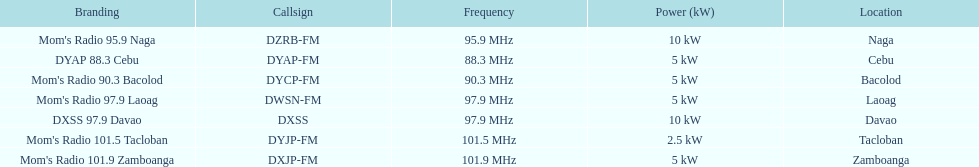Would you mind parsing the complete table? {'header': ['Branding', 'Callsign', 'Frequency', 'Power (kW)', 'Location'], 'rows': [["Mom's Radio 95.9 Naga", 'DZRB-FM', '95.9\xa0MHz', '10\xa0kW', 'Naga'], ['DYAP 88.3 Cebu', 'DYAP-FM', '88.3\xa0MHz', '5\xa0kW', 'Cebu'], ["Mom's Radio 90.3 Bacolod", 'DYCP-FM', '90.3\xa0MHz', '5\xa0kW', 'Bacolod'], ["Mom's Radio 97.9 Laoag", 'DWSN-FM', '97.9\xa0MHz', '5\xa0kW', 'Laoag'], ['DXSS 97.9 Davao', 'DXSS', '97.9\xa0MHz', '10\xa0kW', 'Davao'], ["Mom's Radio 101.5 Tacloban", 'DYJP-FM', '101.5\xa0MHz', '2.5\xa0kW', 'Tacloban'], ["Mom's Radio 101.9 Zamboanga", 'DXJP-FM', '101.9\xa0MHz', '5\xa0kW', 'Zamboanga']]} What is the difference in kw between naga and bacolod radio? 5 kW. 